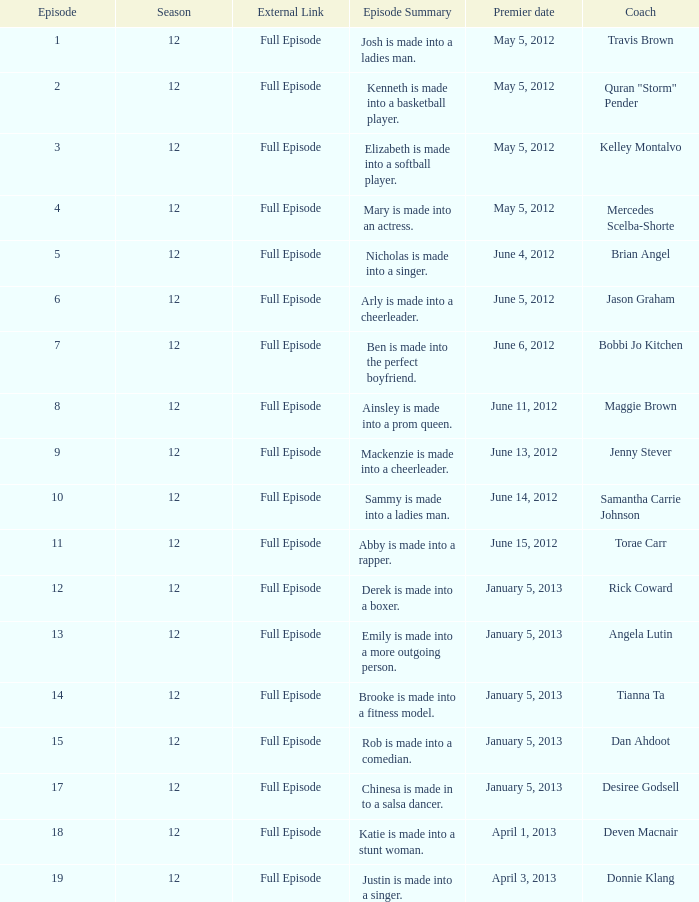Name the episode for travis brown 1.0. 